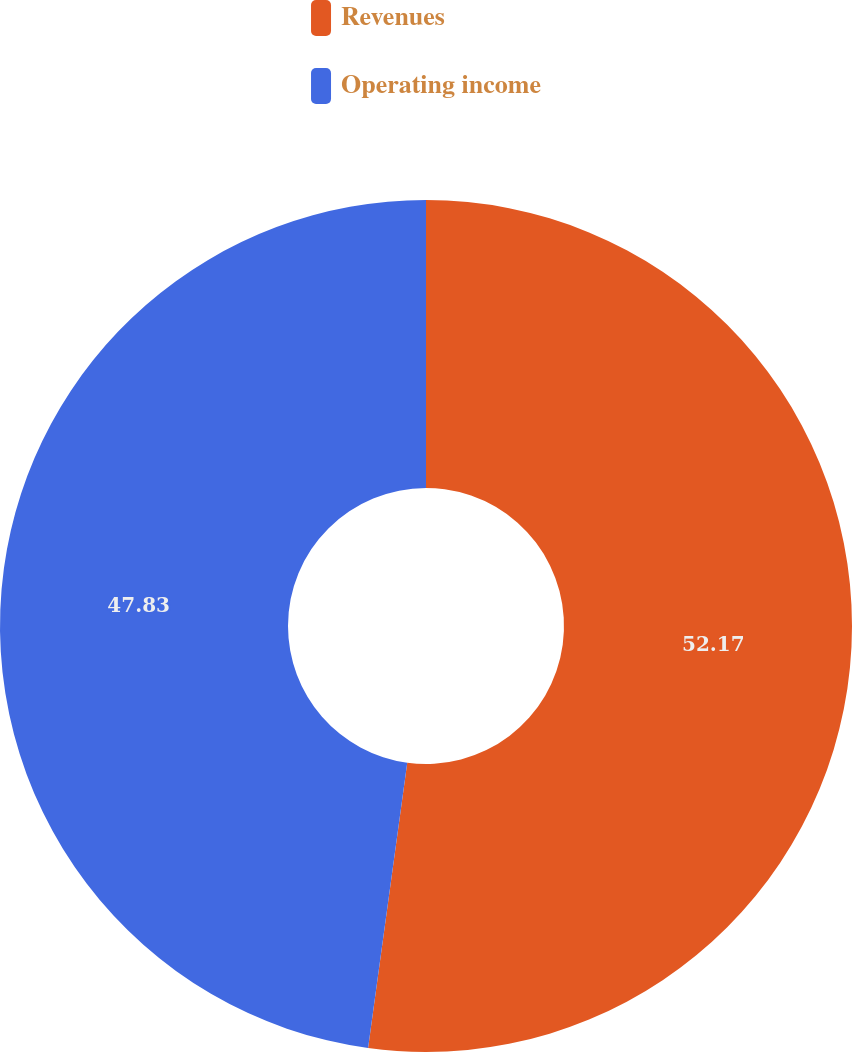Convert chart to OTSL. <chart><loc_0><loc_0><loc_500><loc_500><pie_chart><fcel>Revenues<fcel>Operating income<nl><fcel>52.17%<fcel>47.83%<nl></chart> 